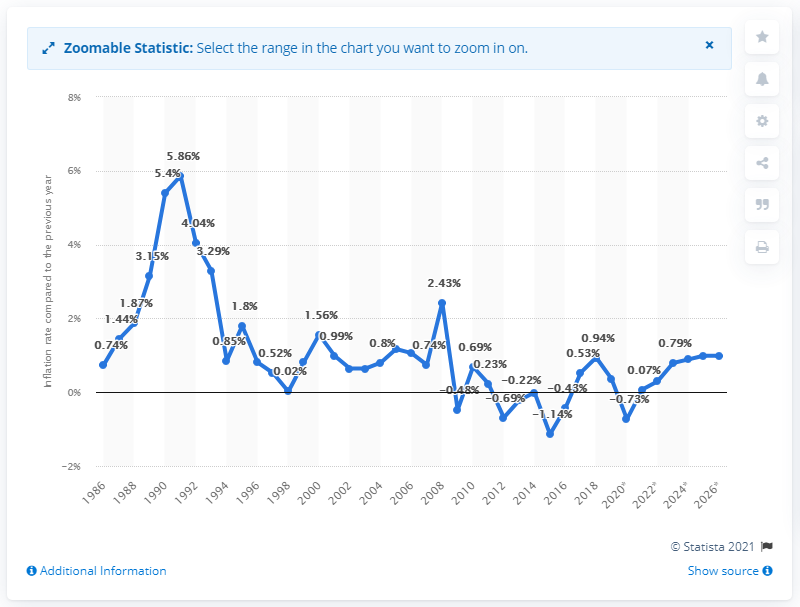Highlight a few significant elements in this photo. In 2019, the inflation rate in Switzerland was 0.36%. 